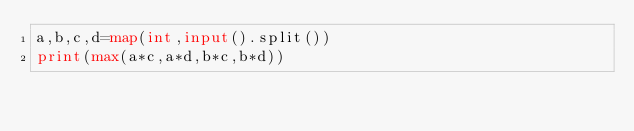Convert code to text. <code><loc_0><loc_0><loc_500><loc_500><_Python_>a,b,c,d=map(int,input().split())
print(max(a*c,a*d,b*c,b*d))</code> 